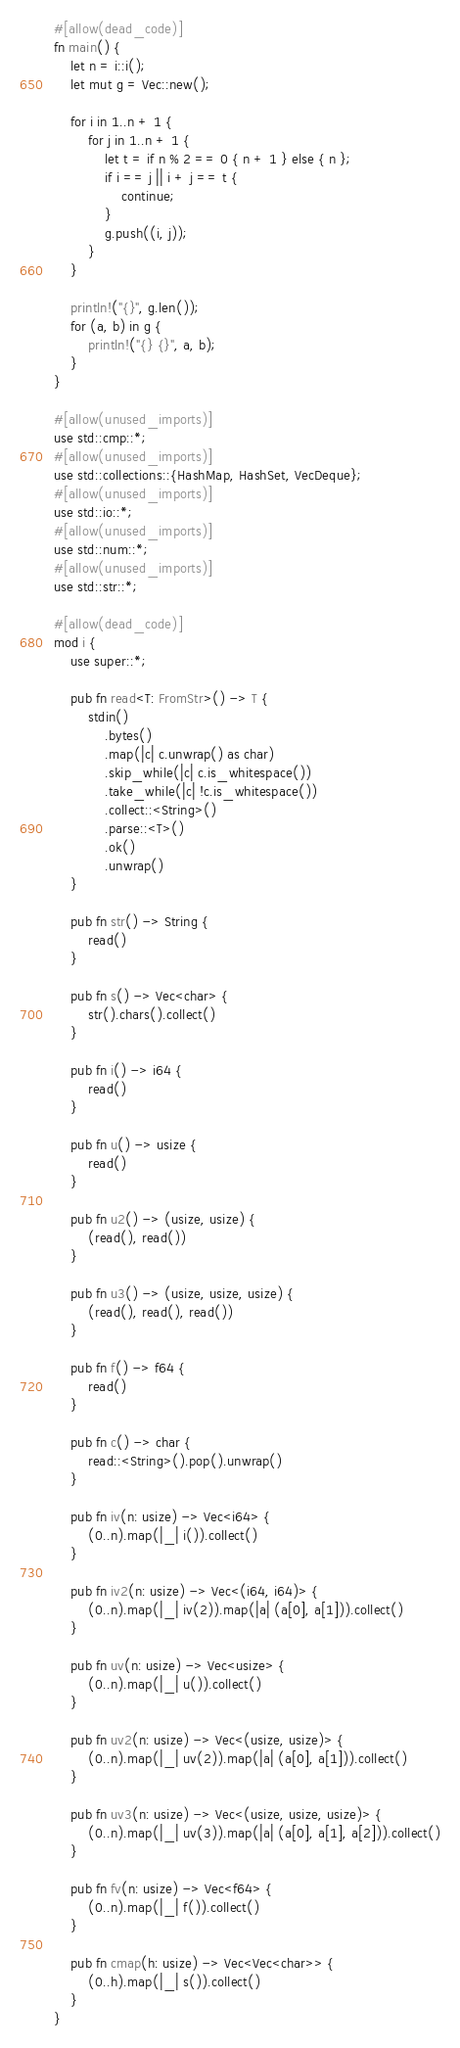Convert code to text. <code><loc_0><loc_0><loc_500><loc_500><_Rust_>#[allow(dead_code)]
fn main() {
    let n = i::i();
    let mut g = Vec::new();

    for i in 1..n + 1 {
        for j in 1..n + 1 {
            let t = if n % 2 == 0 { n + 1 } else { n };
            if i == j || i + j == t {
                continue;
            }
            g.push((i, j));
        }
    }

    println!("{}", g.len());
    for (a, b) in g {
        println!("{} {}", a, b);
    }
}

#[allow(unused_imports)]
use std::cmp::*;
#[allow(unused_imports)]
use std::collections::{HashMap, HashSet, VecDeque};
#[allow(unused_imports)]
use std::io::*;
#[allow(unused_imports)]
use std::num::*;
#[allow(unused_imports)]
use std::str::*;

#[allow(dead_code)]
mod i {
    use super::*;

    pub fn read<T: FromStr>() -> T {
        stdin()
            .bytes()
            .map(|c| c.unwrap() as char)
            .skip_while(|c| c.is_whitespace())
            .take_while(|c| !c.is_whitespace())
            .collect::<String>()
            .parse::<T>()
            .ok()
            .unwrap()
    }

    pub fn str() -> String {
        read()
    }

    pub fn s() -> Vec<char> {
        str().chars().collect()
    }

    pub fn i() -> i64 {
        read()
    }

    pub fn u() -> usize {
        read()
    }

    pub fn u2() -> (usize, usize) {
        (read(), read())
    }

    pub fn u3() -> (usize, usize, usize) {
        (read(), read(), read())
    }

    pub fn f() -> f64 {
        read()
    }

    pub fn c() -> char {
        read::<String>().pop().unwrap()
    }

    pub fn iv(n: usize) -> Vec<i64> {
        (0..n).map(|_| i()).collect()
    }

    pub fn iv2(n: usize) -> Vec<(i64, i64)> {
        (0..n).map(|_| iv(2)).map(|a| (a[0], a[1])).collect()
    }

    pub fn uv(n: usize) -> Vec<usize> {
        (0..n).map(|_| u()).collect()
    }

    pub fn uv2(n: usize) -> Vec<(usize, usize)> {
        (0..n).map(|_| uv(2)).map(|a| (a[0], a[1])).collect()
    }

    pub fn uv3(n: usize) -> Vec<(usize, usize, usize)> {
        (0..n).map(|_| uv(3)).map(|a| (a[0], a[1], a[2])).collect()
    }

    pub fn fv(n: usize) -> Vec<f64> {
        (0..n).map(|_| f()).collect()
    }

    pub fn cmap(h: usize) -> Vec<Vec<char>> {
        (0..h).map(|_| s()).collect()
    }
}
</code> 